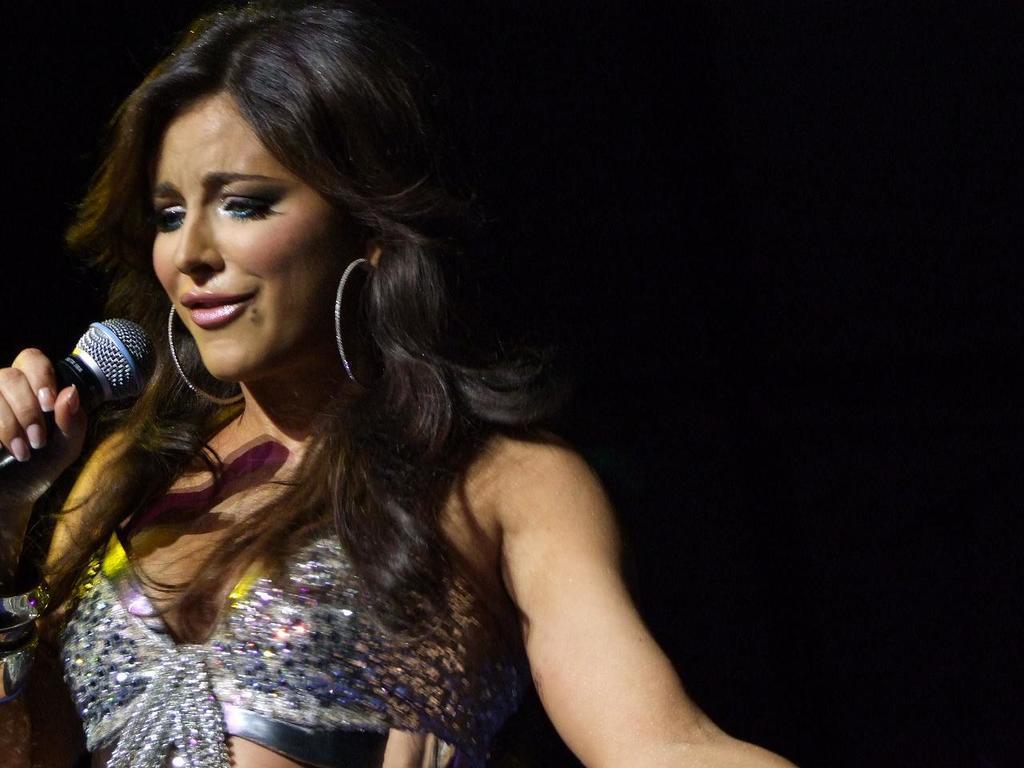Can you describe this image briefly? In this picture there is a woman who is holding a mic. She is smiling. 